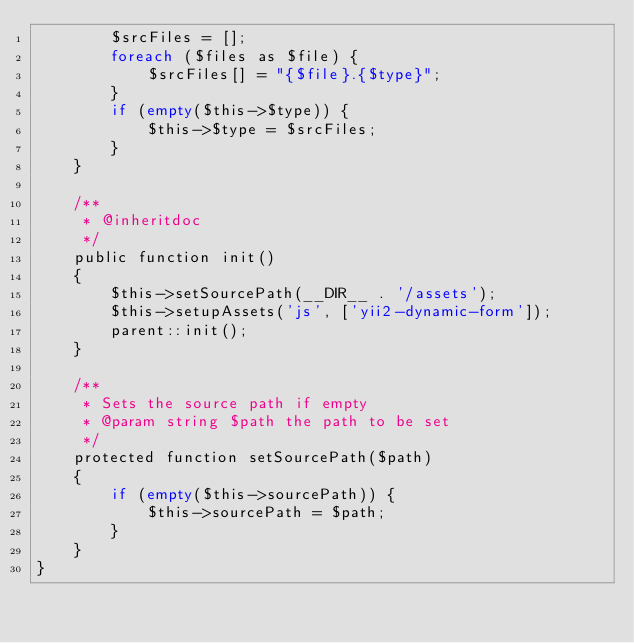<code> <loc_0><loc_0><loc_500><loc_500><_PHP_>        $srcFiles = [];
        foreach ($files as $file) {
            $srcFiles[] = "{$file}.{$type}";
        }
        if (empty($this->$type)) {
            $this->$type = $srcFiles;
        }
    }

    /**
     * @inheritdoc
     */
    public function init()
    {
        $this->setSourcePath(__DIR__ . '/assets');
        $this->setupAssets('js', ['yii2-dynamic-form']);
        parent::init();
    }

    /**
     * Sets the source path if empty
     * @param string $path the path to be set
     */
    protected function setSourcePath($path)
    {
        if (empty($this->sourcePath)) {
            $this->sourcePath = $path;
        }
    }
}
</code> 